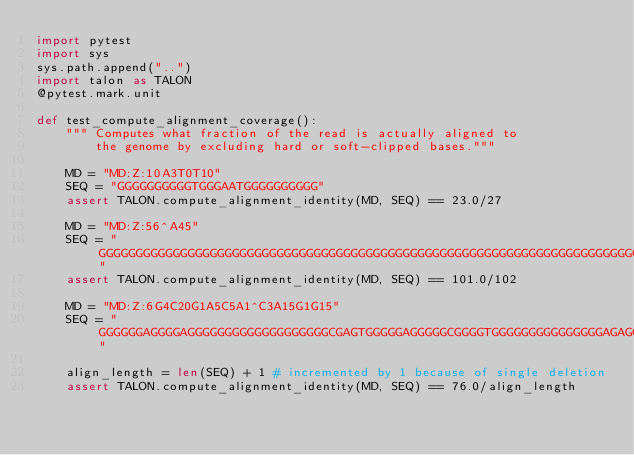Convert code to text. <code><loc_0><loc_0><loc_500><loc_500><_Python_>import pytest
import sys
sys.path.append("..")
import talon as TALON
@pytest.mark.unit

def test_compute_alignment_coverage():
    """ Computes what fraction of the read is actually aligned to
        the genome by excluding hard or soft-clipped bases."""
    
    MD = "MD:Z:10A3T0T10"
    SEQ = "GGGGGGGGGGTGGGAATGGGGGGGGGG"
    assert TALON.compute_alignment_identity(MD, SEQ) == 23.0/27

    MD = "MD:Z:56^A45"
    SEQ = "GGGGGGGGGGGGGGGGGGGGGGGGGGGGGGGGGGGGGGGGGGGGGGGGGGGGGGGGGGGGGGGGGGGGGGGGGGGGGGGGGGGGGGGGGGGGGGGGGGGGG"
    assert TALON.compute_alignment_identity(MD, SEQ) == 101.0/102

    MD = "MD:Z:6G4C20G1A5C5A1^C3A15G1G15"
    SEQ = "GGGGGGAGGGGAGGGGGGGGGGGGGGGGGGGCGAGTGGGGGAGGGGGCGGGGTGGGGGGGGGGGGGGGAGAGGGGGGGGGGGGGGG" 

    align_length = len(SEQ) + 1 # incremented by 1 because of single deletion
    assert TALON.compute_alignment_identity(MD, SEQ) == 76.0/align_length
</code> 